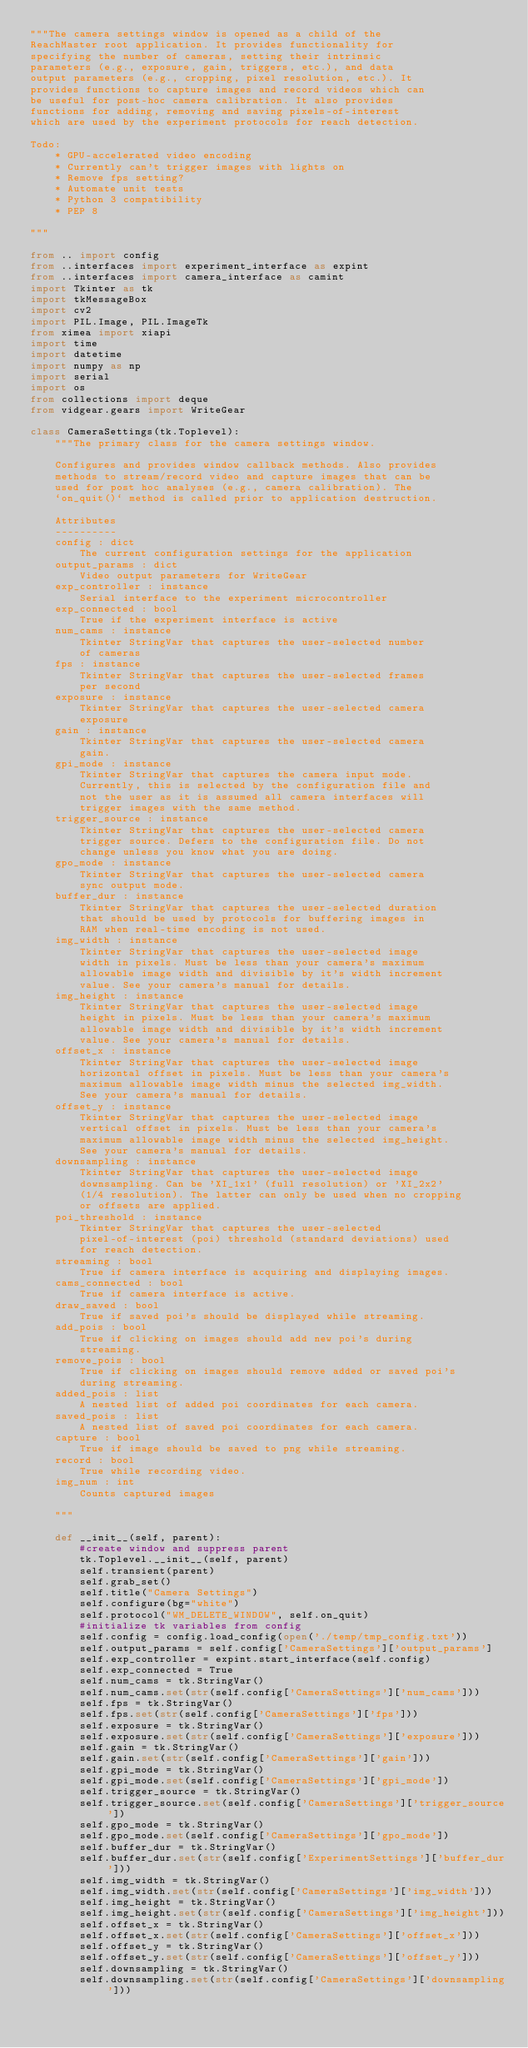<code> <loc_0><loc_0><loc_500><loc_500><_Python_>"""The camera settings window is opened as a child of the 
ReachMaster root application. It provides functionality for 
specifying the number of cameras, setting their intrinsic 
parameters (e.g., exposure, gain, triggers, etc.), and data 
output parameters (e.g., cropping, pixel resolution, etc.). It 
provides functions to capture images and record videos which can
be useful for post-hoc camera calibration. It also provides 
functions for adding, removing and saving pixels-of-interest 
which are used by the experiment protocols for reach detection.

Todo:
    * GPU-accelerated video encoding
    * Currently can't trigger images with lights on
    * Remove fps setting? 
    * Automate unit tests
    * Python 3 compatibility
    * PEP 8

"""

from .. import config
from ..interfaces import experiment_interface as expint
from ..interfaces import camera_interface as camint
import Tkinter as tk 
import tkMessageBox
import cv2
import PIL.Image, PIL.ImageTk
from ximea import xiapi
import time
import datetime
import numpy as np
import serial
import os 
from collections import deque
from vidgear.gears import WriteGear

class CameraSettings(tk.Toplevel):
    """The primary class for the camera settings window.

    Configures and provides window callback methods. Also provides 
    methods to stream/record video and capture images that can be 
    used for post hoc analyses (e.g., camera calibration). The 
    `on_quit()` method is called prior to application destruction.   

    Attributes
    ----------
    config : dict
        The current configuration settings for the application
    output_params : dict
        Video output parameters for WriteGear
    exp_controller : instance
        Serial interface to the experiment microcontroller
    exp_connected : bool 
        True if the experiment interface is active
    num_cams : instance
        Tkinter StringVar that captures the user-selected number 
        of cameras
    fps : instance 
        Tkinter StringVar that captures the user-selected frames 
        per second
    exposure : instance 
        Tkinter StringVar that captures the user-selected camera 
        exposure
    gain : instance 
        Tkinter StringVar that captures the user-selected camera 
        gain.
    gpi_mode : instance 
        Tkinter StringVar that captures the camera input mode. 
        Currently, this is selected by the configuration file and 
        not the user as it is assumed all camera interfaces will 
        trigger images with the same method.
    trigger_source : instance 
        Tkinter StringVar that captures the user-selected camera 
        trigger source. Defers to the configuration file. Do not 
        change unless you know what you are doing.
    gpo_mode : instance 
        Tkinter StringVar that captures the user-selected camera 
        sync output mode.
    buffer_dur : instance 
        Tkinter StringVar that captures the user-selected duration 
        that should be used by protocols for buffering images in 
        RAM when real-time encoding is not used. 
    img_width : instance 
        Tkinter StringVar that captures the user-selected image 
        width in pixels. Must be less than your camera's maximum 
        allowable image width and divisible by it's width increment 
        value. See your camera's manual for details.
    img_height : instance 
        Tkinter StringVar that captures the user-selected image 
        height in pixels. Must be less than your camera's maximum 
        allowable image width and divisible by it's width increment 
        value. See your camera's manual for details. 
    offset_x : instance 
        Tkinter StringVar that captures the user-selected image 
        horizontal offset in pixels. Must be less than your camera's
        maximum allowable image width minus the selected img_width. 
        See your camera's manual for details.
    offset_y : instance 
        Tkinter StringVar that captures the user-selected image 
        vertical offset in pixels. Must be less than your camera's 
        maximum allowable image width minus the selected img_height. 
        See your camera's manual for details.
    downsampling : instance
        Tkinter StringVar that captures the user-selected image 
        downsampling. Can be 'XI_1x1' (full resolution) or 'XI_2x2' 
        (1/4 resolution). The latter can only be used when no cropping 
        or offsets are applied. 
    poi_threshold : instance 
        Tkinter StringVar that captures the user-selected 
        pixel-of-interest (poi) threshold (standard deviations) used 
        for reach detection.
    streaming : bool
        True if camera interface is acquiring and displaying images.
    cams_connected : bool
        True if camera interface is active.
    draw_saved : bool 
        True if saved poi's should be displayed while streaming.
    add_pois : bool 
        True if clicking on images should add new poi's during 
        streaming.
    remove_pois : bool
        True if clicking on images should remove added or saved poi's 
        during streaming.
    added_pois : list 
        A nested list of added poi coordinates for each camera. 
    saved_pois : list
        A nested list of saved poi coordinates for each camera. 
    capture : bool
        True if image should be saved to png while streaming.
    record : bool
        True while recording video.
    img_num : int 
        Counts captured images 

    """

    def __init__(self, parent):
        #create window and suppress parent
        tk.Toplevel.__init__(self, parent)
        self.transient(parent) 
        self.grab_set()
        self.title("Camera Settings")
        self.configure(bg="white")
        self.protocol("WM_DELETE_WINDOW", self.on_quit) 
        #initialize tk variables from config
        self.config = config.load_config(open('./temp/tmp_config.txt'))
        self.output_params = self.config['CameraSettings']['output_params']        
        self.exp_controller = expint.start_interface(self.config)
        self.exp_connected = True       
        self.num_cams = tk.StringVar()
        self.num_cams.set(str(self.config['CameraSettings']['num_cams']))
        self.fps = tk.StringVar()
        self.fps.set(str(self.config['CameraSettings']['fps']))
        self.exposure = tk.StringVar()
        self.exposure.set(str(self.config['CameraSettings']['exposure']))
        self.gain = tk.StringVar()
        self.gain.set(str(self.config['CameraSettings']['gain']))   
        self.gpi_mode = tk.StringVar()
        self.gpi_mode.set(self.config['CameraSettings']['gpi_mode'])
        self.trigger_source = tk.StringVar()
        self.trigger_source.set(self.config['CameraSettings']['trigger_source'])
        self.gpo_mode = tk.StringVar()
        self.gpo_mode.set(self.config['CameraSettings']['gpo_mode'])
        self.buffer_dur = tk.StringVar()
        self.buffer_dur.set(str(self.config['ExperimentSettings']['buffer_dur']))
        self.img_width = tk.StringVar()
        self.img_width.set(str(self.config['CameraSettings']['img_width']))
        self.img_height = tk.StringVar()
        self.img_height.set(str(self.config['CameraSettings']['img_height']))
        self.offset_x = tk.StringVar()
        self.offset_x.set(str(self.config['CameraSettings']['offset_x']))
        self.offset_y = tk.StringVar()
        self.offset_y.set(str(self.config['CameraSettings']['offset_y']))
        self.downsampling = tk.StringVar()
        self.downsampling.set(str(self.config['CameraSettings']['downsampling']))</code> 